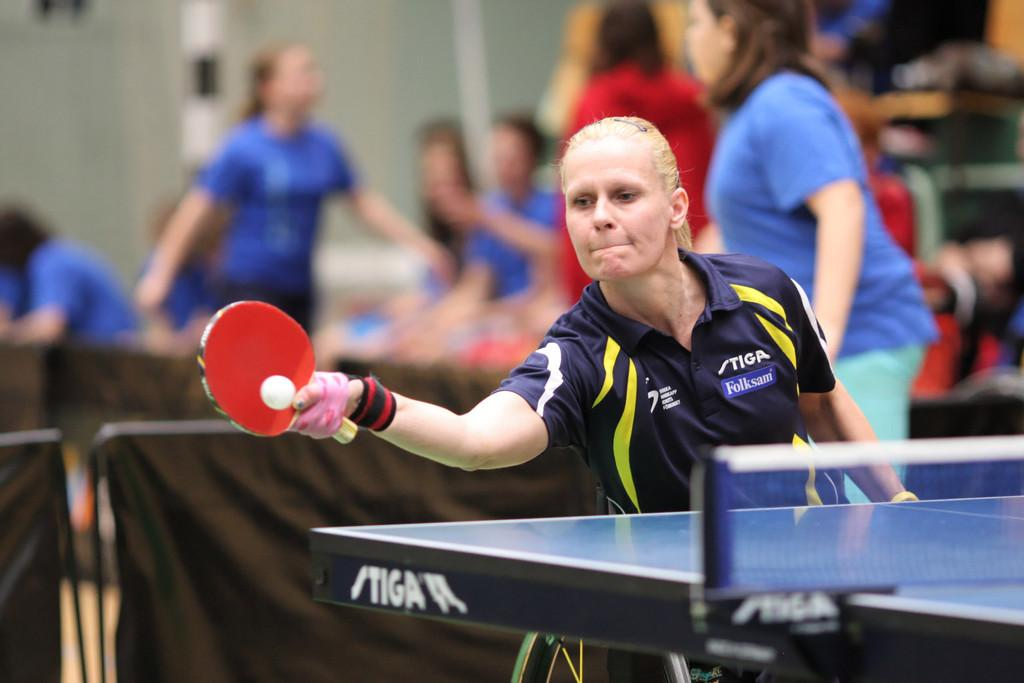Who is the main subject in the image? There is a woman in the image. What is the woman doing in the image? The woman is playing table tennis. What type of store can be seen in the background of the image? There is no store visible in the image; it only features a woman playing table tennis. How many toes are visible on the woman's feet in the image? The image does not show the woman's feet, so it is impossible to determine the number of toes visible. 